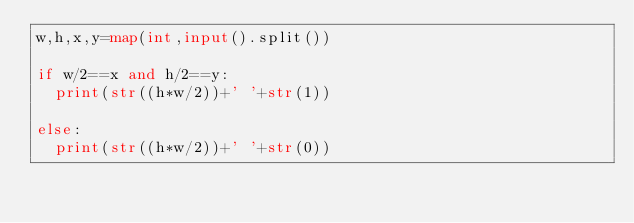<code> <loc_0><loc_0><loc_500><loc_500><_Python_>w,h,x,y=map(int,input().split())

if w/2==x and h/2==y:
  print(str((h*w/2))+' '+str(1))
  
else:
  print(str((h*w/2))+' '+str(0))

</code> 